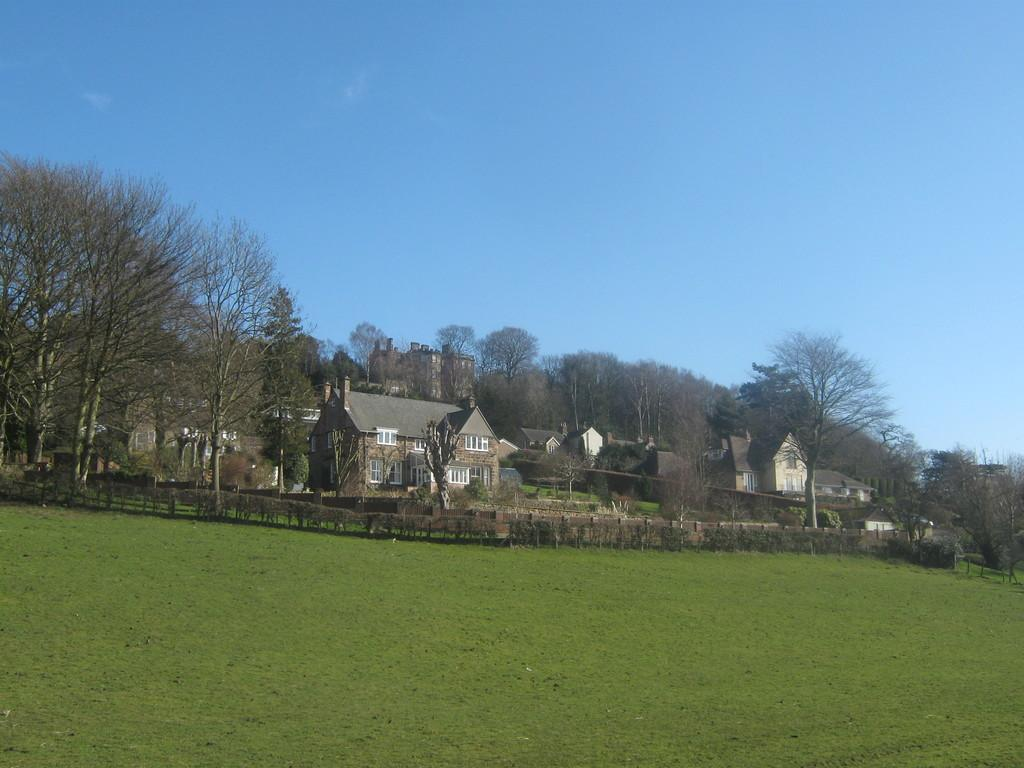What type of vegetation can be seen in the image? There is grass in the image. What structures are present in the image? There are buildings in the image. What other natural elements can be seen in the image? There are trees in the image. What is visible in the background of the image? The sky is visible in the background of the image. Where is the pump located in the image? There is no pump present in the image. What type of ticket can be seen in the image? There is no ticket present in the image. 